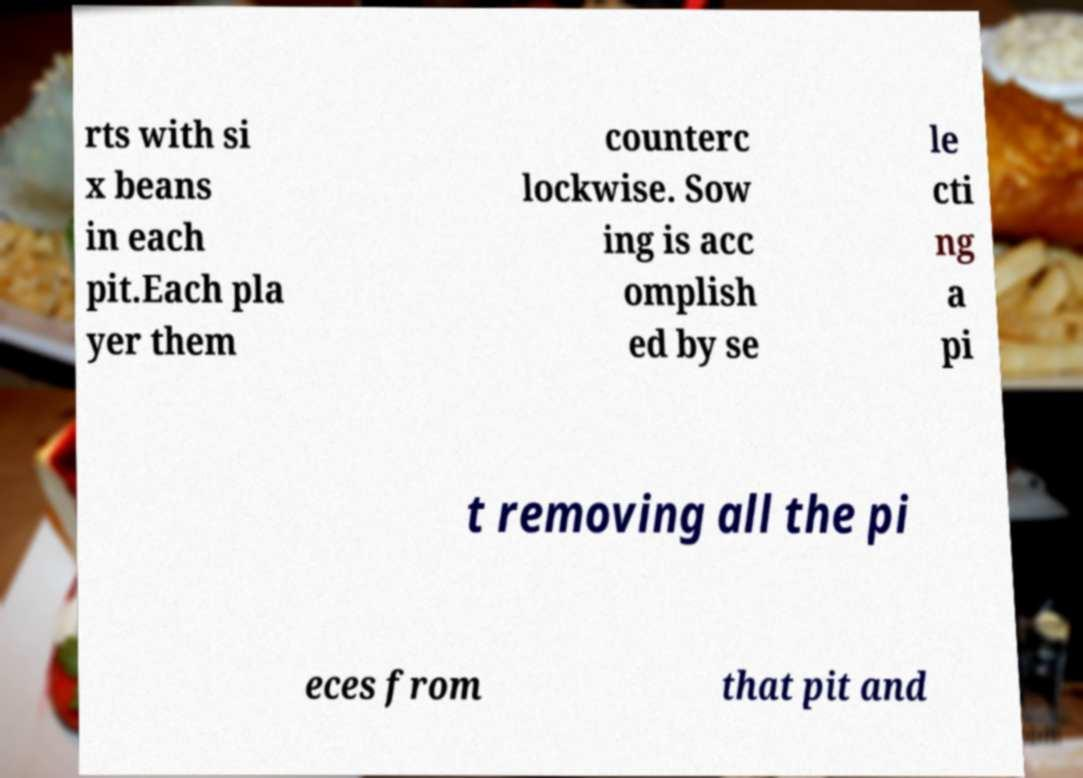Could you assist in decoding the text presented in this image and type it out clearly? rts with si x beans in each pit.Each pla yer them counterc lockwise. Sow ing is acc omplish ed by se le cti ng a pi t removing all the pi eces from that pit and 